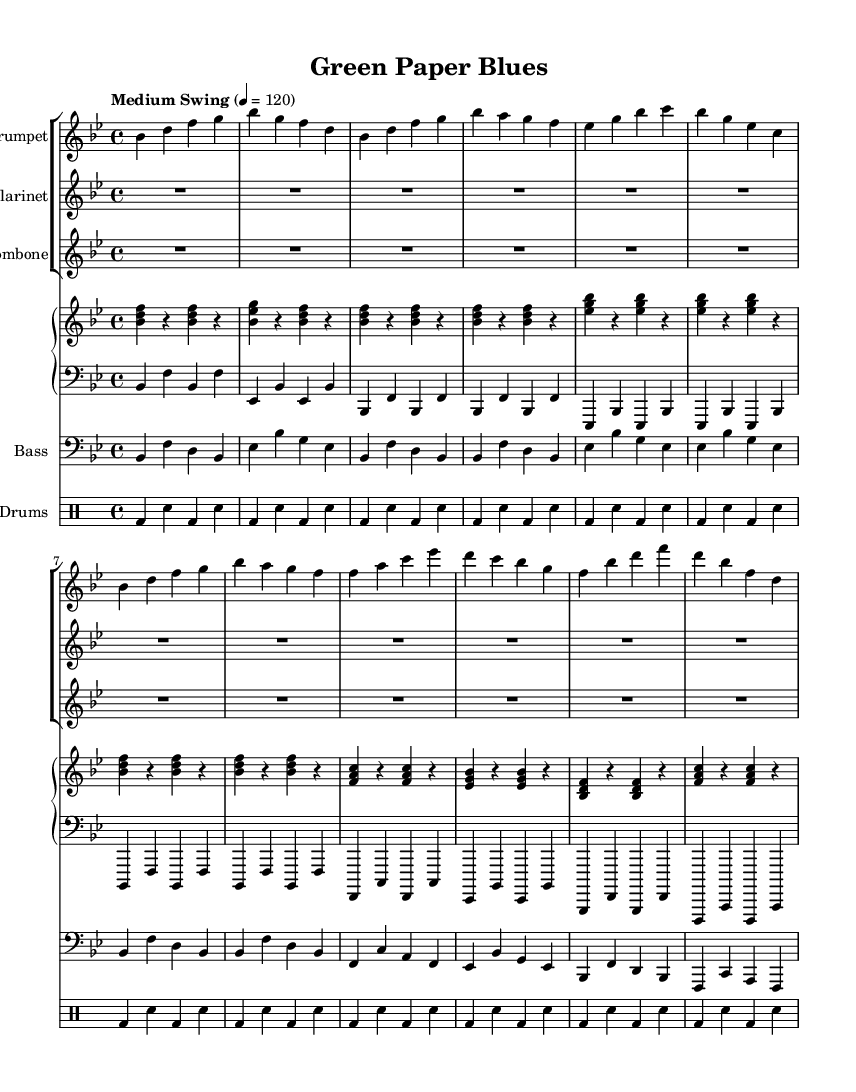What is the key signature of this music? The key signature is identified at the beginning of the staff, indicating the number of sharps or flats. In this case, the key signature has a flat (bes) which indicates it is in B flat major.
Answer: B flat major What is the time signature of this music? The time signature is found at the beginning of the music sheet, which shows how many beats are in each measure. In this piece, it displays 4/4, meaning there are four beats per measure.
Answer: 4/4 What tempo marking is indicated for this music? The tempo marking is written above the music indicating how fast the piece should be played. Here, it states "Medium Swing," which implies a moderate swing feel.
Answer: Medium Swing How many measures does the trumpet music contain? The trumpet part consists of a series of notes divided into measures. By counting the separate groups of notes between the vertical lines (bar lines), the total number of measures is calculated. The trumpet part has 12 measures.
Answer: 12 What types of instruments are featured in this piece? The ensemble consists of multiple instruments, which can be identified by their respective staves. This piece includes trumpet, clarinet, trombone, piano, bass, and drums, showcasing a typical jazz band configuration.
Answer: Trumpet, clarinet, trombone, piano, bass, drums Which section of the music does the piano play? The piano part is divided into two sections: the right hand (pianoRH) and the left hand (pianoLH). By examining the layout of the staves, we see that the piano accompanies the other instruments in both harmonic and rhythmic support.
Answer: Upper and lower piano parts What is the primary style of this music? The overall structure, swing feel, and improvisational elements are characteristic of jazz music. In addition, the title "Green Paper Blues" implies an environmental theme within a jazz context, merging musical style with a conservation message.
Answer: Jazz 